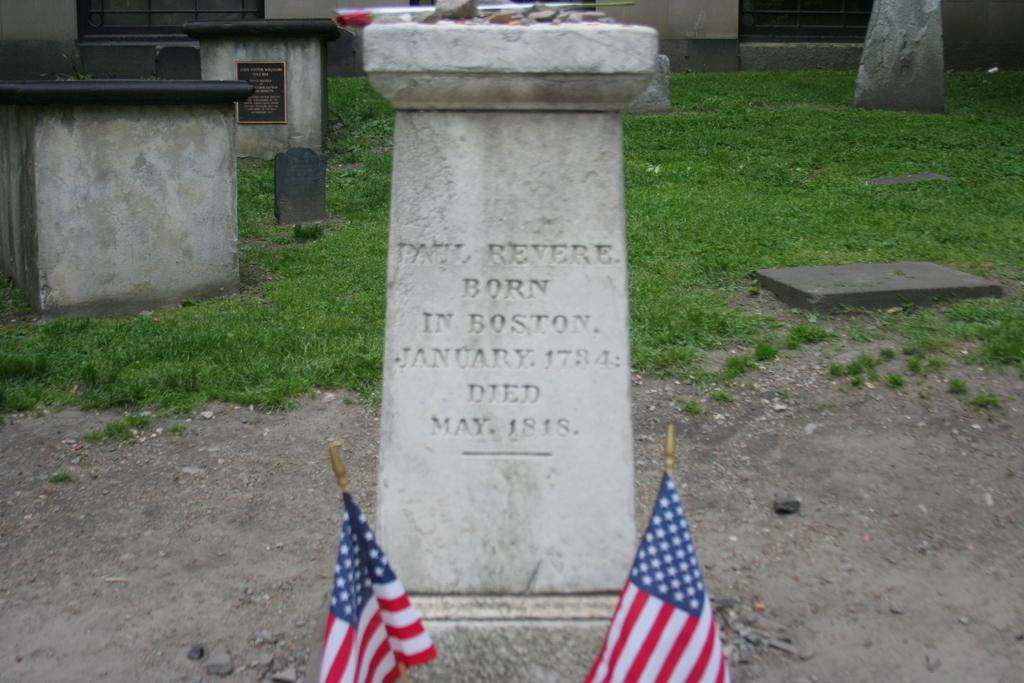What is the main subject in the middle of the picture? There is a gravestone in the middle of the picture. What type of vegetation can be seen in the background of the picture? There is grass visible in the background of the picture. What level of experience does the thread have in the picture? There is no thread present in the image, so it is not possible to determine its level of experience. 